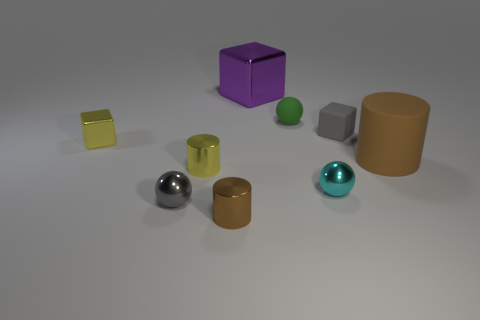Subtract all small blocks. How many blocks are left? 1 Subtract all red balls. How many brown cylinders are left? 2 Subtract all yellow cylinders. How many cylinders are left? 2 Subtract all cylinders. How many objects are left? 6 Add 1 purple objects. How many purple objects exist? 2 Subtract 0 red cubes. How many objects are left? 9 Subtract all blue balls. Subtract all gray blocks. How many balls are left? 3 Subtract all small yellow metallic blocks. Subtract all big metal cubes. How many objects are left? 7 Add 4 tiny green spheres. How many tiny green spheres are left? 5 